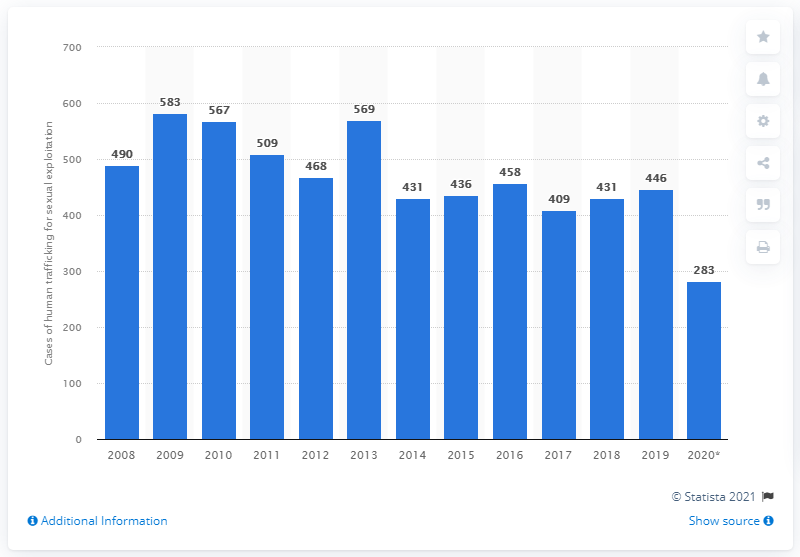How reliable do you think the data shown in this chart is? The reliability of the data in the chart depends on several factors, such as the methodology used in data collection, the source's credibility, and whether the figures have been corroborated by multiple reports or agencies. The chart indicates that it's sourced from Statista 2021, which is generally a reputable aggregator of statistical data. However, it is always advisable to refer to multiple sources and consider the potential for underreporting or changes in reporting practices when forming an opinion on the reliability of such sensitive data. 